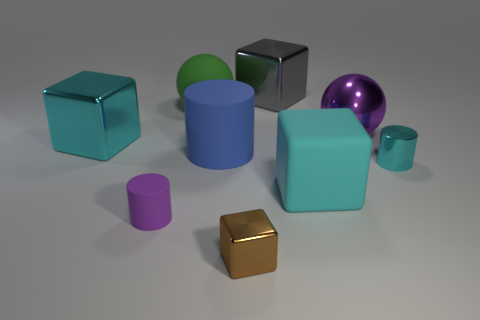What number of rubber spheres have the same size as the brown metallic thing?
Give a very brief answer. 0. Are any big yellow cylinders visible?
Ensure brevity in your answer.  No. Are there any other things that are the same color as the big cylinder?
Your answer should be compact. No. What shape is the cyan thing that is the same material as the cyan cylinder?
Keep it short and to the point. Cube. What color is the tiny shiny thing that is to the right of the large cyan thing right of the sphere behind the big shiny ball?
Give a very brief answer. Cyan. Is the number of large purple metal balls that are left of the tiny brown metallic object the same as the number of small brown things?
Keep it short and to the point. No. Are there any other things that have the same material as the large purple ball?
Provide a succinct answer. Yes. Do the matte block and the metallic block that is behind the large cyan metallic block have the same color?
Ensure brevity in your answer.  No. Is there a big green rubber ball that is in front of the cyan matte thing in front of the cyan object on the right side of the cyan rubber thing?
Provide a succinct answer. No. Are there fewer purple rubber objects in front of the purple ball than big yellow metal cylinders?
Offer a terse response. No. 